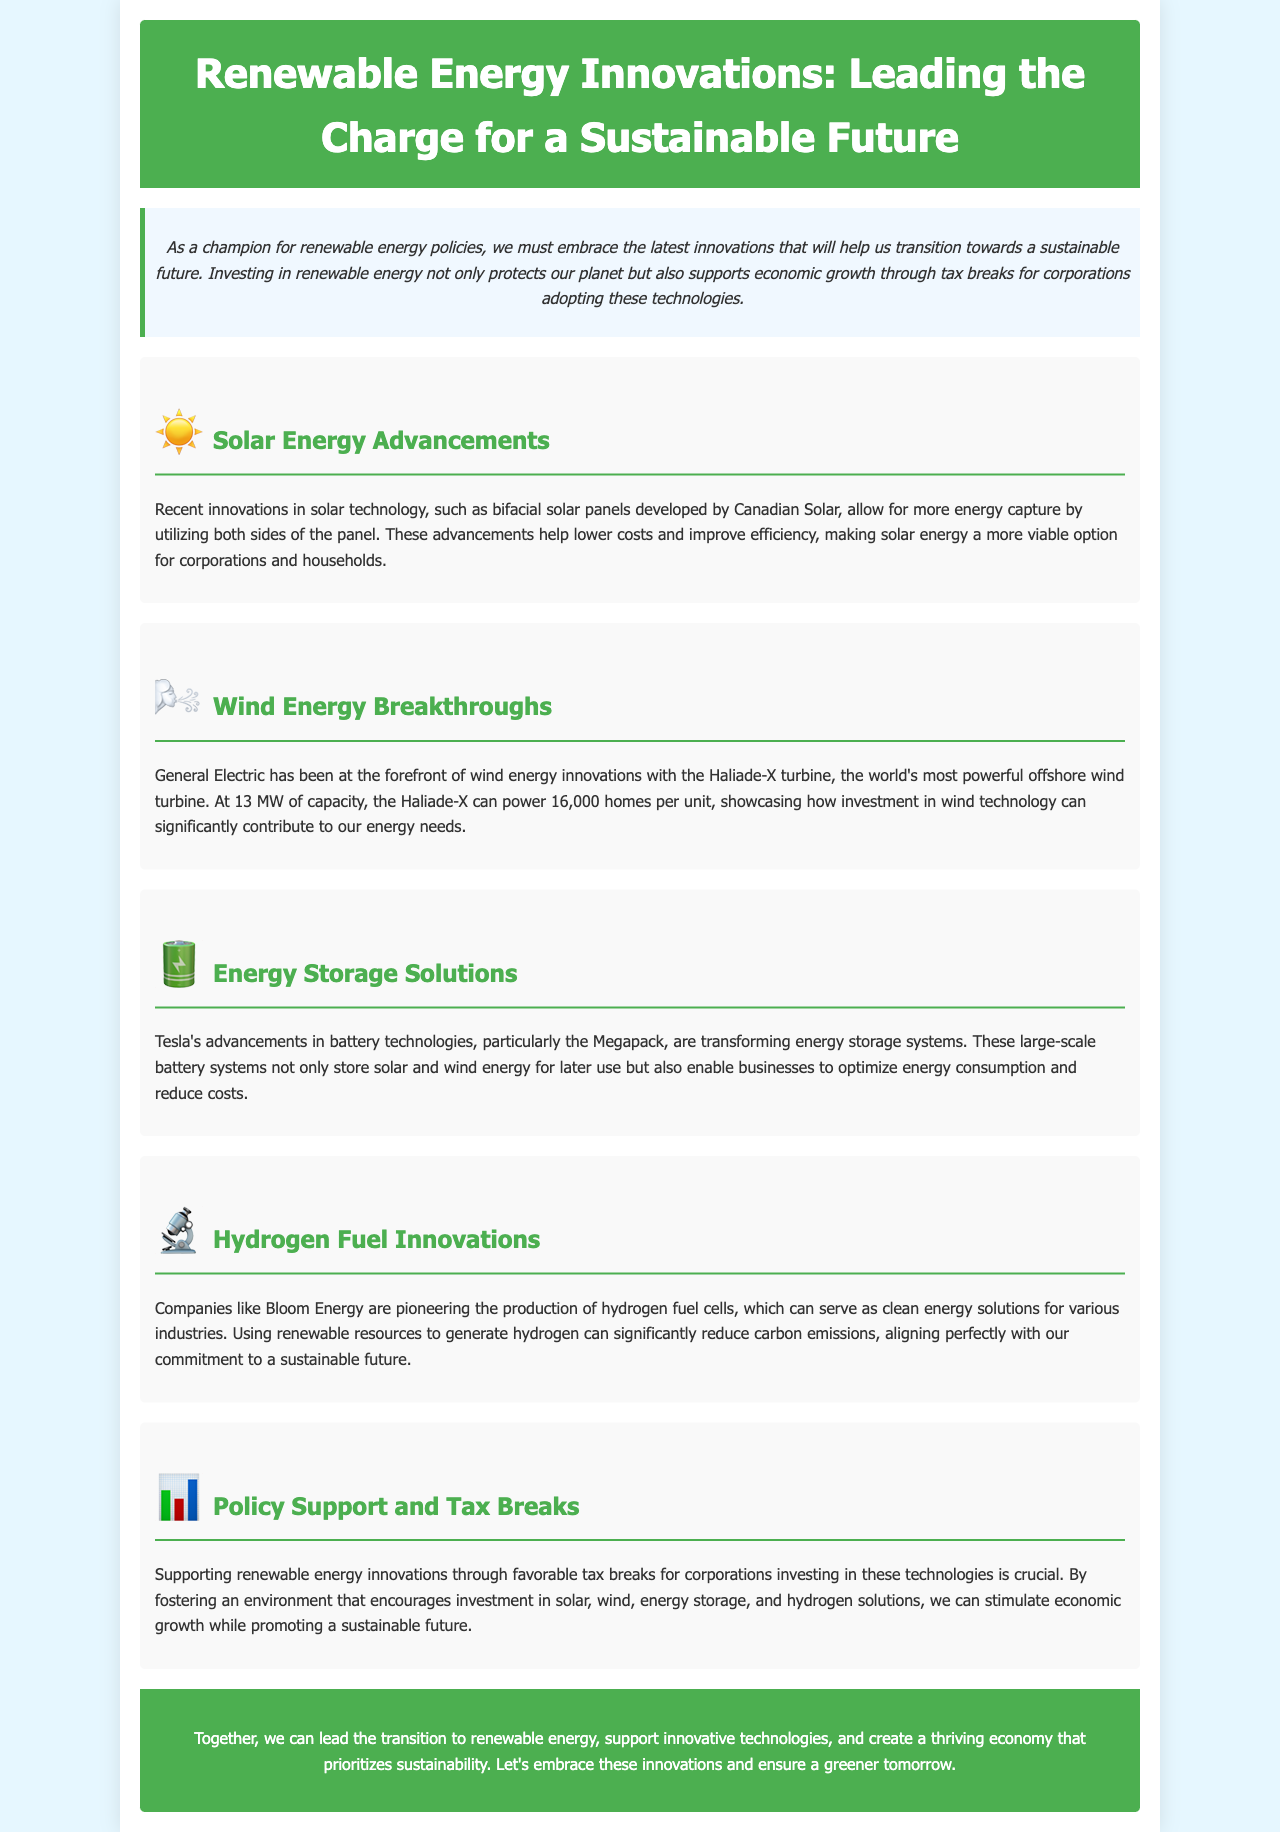What is the title of the brochure? The title is prominently displayed in the header of the document.
Answer: Renewable Energy Innovations: Leading the Charge for a Sustainable Future Who developed bifacial solar panels? The document states that Canadian Solar is the developer of bifacial solar panels.
Answer: Canadian Solar What is the capacity of the Haliade-X turbine? The document specifies the capacity of the Haliade-X turbine in megawatts.
Answer: 13 MW What does Tesla's Megapack do? The document describes the function of the Megapack in terms of energy storage.
Answer: Transforming energy storage systems Which company is pioneering hydrogen fuel cells? The document mentions the company that is leading in hydrogen fuel cell technology.
Answer: Bloom Energy How many homes can one Haliade-X unit power? The document provides information on how many homes can be powered by one unit of Haliade-X.
Answer: 16,000 homes What is the main focus of the policy support mentioned? The document indicates the purpose of policy support and tax breaks for corporations.
Answer: Encouraging investment in renewable technologies What is highlighted as crucial for supporting renewable energy innovations? The document emphasizes an essential action for promoting renewable energy innovations.
Answer: Favorable tax breaks 